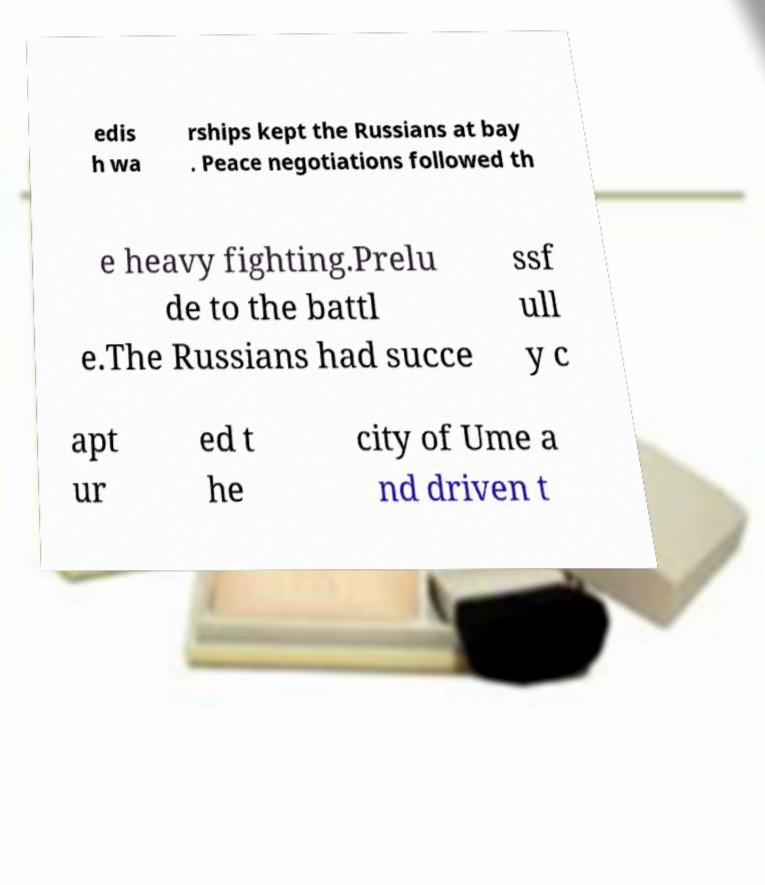Please read and relay the text visible in this image. What does it say? edis h wa rships kept the Russians at bay . Peace negotiations followed th e heavy fighting.Prelu de to the battl e.The Russians had succe ssf ull y c apt ur ed t he city of Ume a nd driven t 